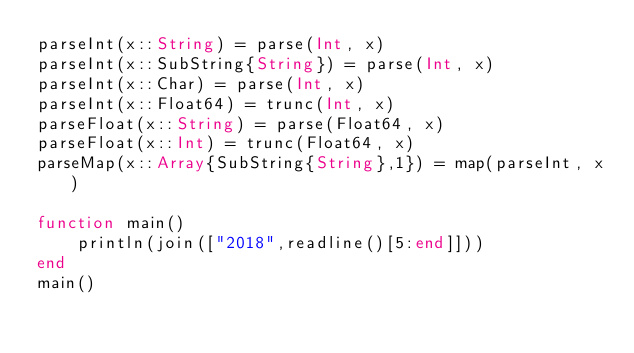Convert code to text. <code><loc_0><loc_0><loc_500><loc_500><_Julia_>parseInt(x::String) = parse(Int, x)
parseInt(x::SubString{String}) = parse(Int, x)
parseInt(x::Char) = parse(Int, x)
parseInt(x::Float64) = trunc(Int, x)
parseFloat(x::String) = parse(Float64, x)
parseFloat(x::Int) = trunc(Float64, x)
parseMap(x::Array{SubString{String},1}) = map(parseInt, x)

function main()
    println(join(["2018",readline()[5:end]]))
end
main()</code> 